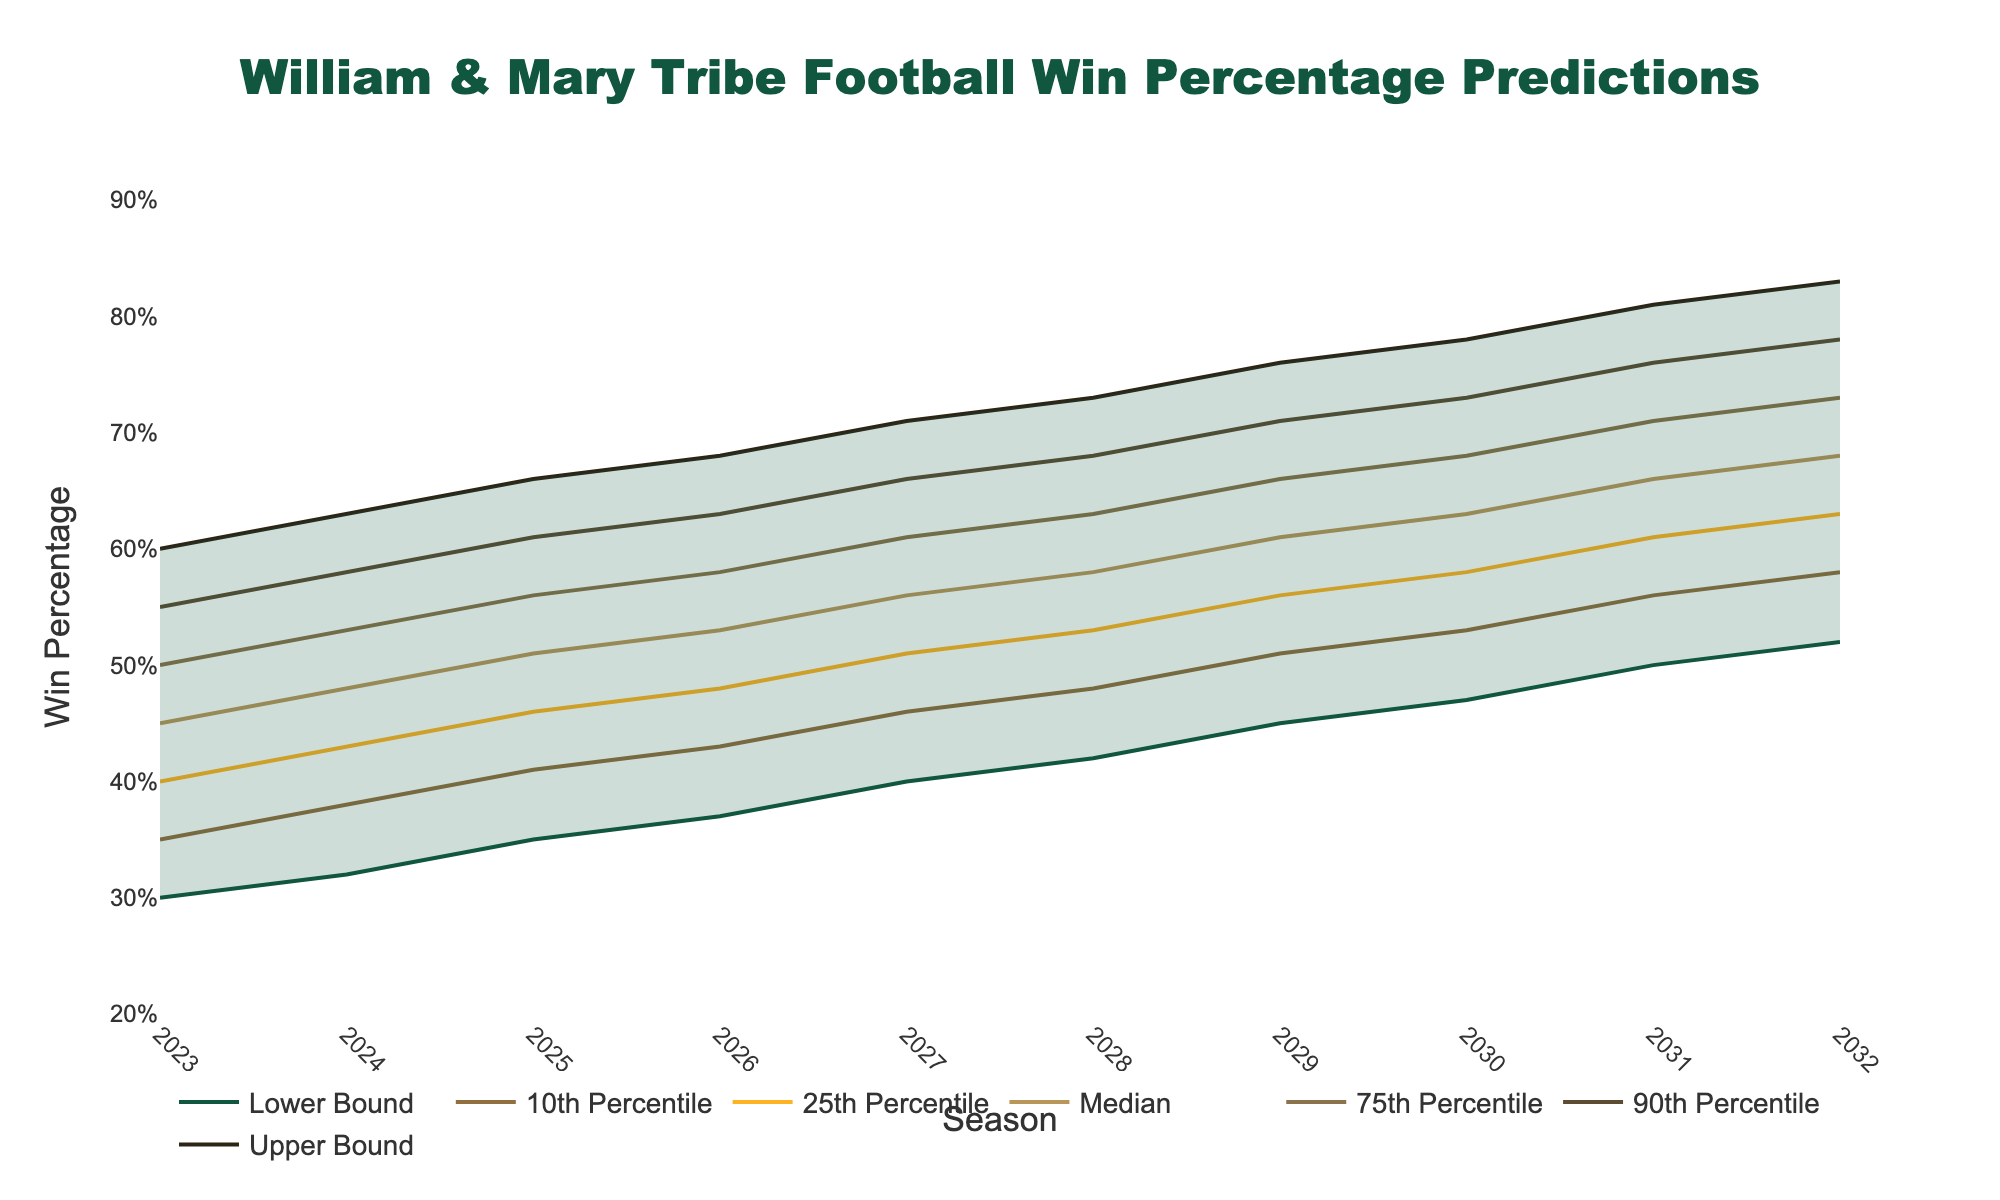What is the title of the figure? The title can be found at the top of the chart, where it shows a descriptive summary of the chart's main purpose or content.
Answer: William & Mary Tribe Football Win Percentage Predictions Which season has the highest median win percentage? Locate the "Median" series and identify the highest point along the y-axis, then trace it to the corresponding season on the x-axis.
Answer: 2032 What is the range of win percentages predicted for the season 2028? For 2028, look at the Lower Bound and Upper Bound values on the y-axis for the season. The range is calculated as Upper Bound minus Lower Bound (0.73 - 0.42 = 0.31).
Answer: 0.31 What is the median predicted win percentage for the 2025 season? Find the intersection of the "Median" series with the 2025 season on the x-axis, then read the corresponding value on the y-axis.
Answer: 0.51 By how much does the median predicted win percentage increase from 2023 to 2032? Find the median win percentages for both 2023 and 2032, then subtract the 2023 value from the 2032 value (0.68 - 0.45 = 0.23).
Answer: 0.23 Which year shows the smallest difference between the upper and lower bounds of win percentage predictions? For each year, calculate the difference between the Upper Bound and Lower Bound values, then identify the smallest difference. Use values as follows: 2023(0.6-0.3=0.3), 2024(0.63-0.32=0.31), ..., 2032 (0.83-0.52=0.31).
Answer: 2023 In which season does the 75th percentile prediction first reach at least 0.70 win percentage? Identify the first point along the "75th Percentile" series that reaches or exceeds 0.70, and trace it back to the season on the x-axis.
Answer: 2030 How does the 10th percentile prediction change from 2023 to 2029? Compare the 10th percentile values at 2023 and 2029. Note the increment by subtracting the 2023 value from the 2029 value (0.51 - 0.35 = 0.16).
Answer: Increases by 0.16 